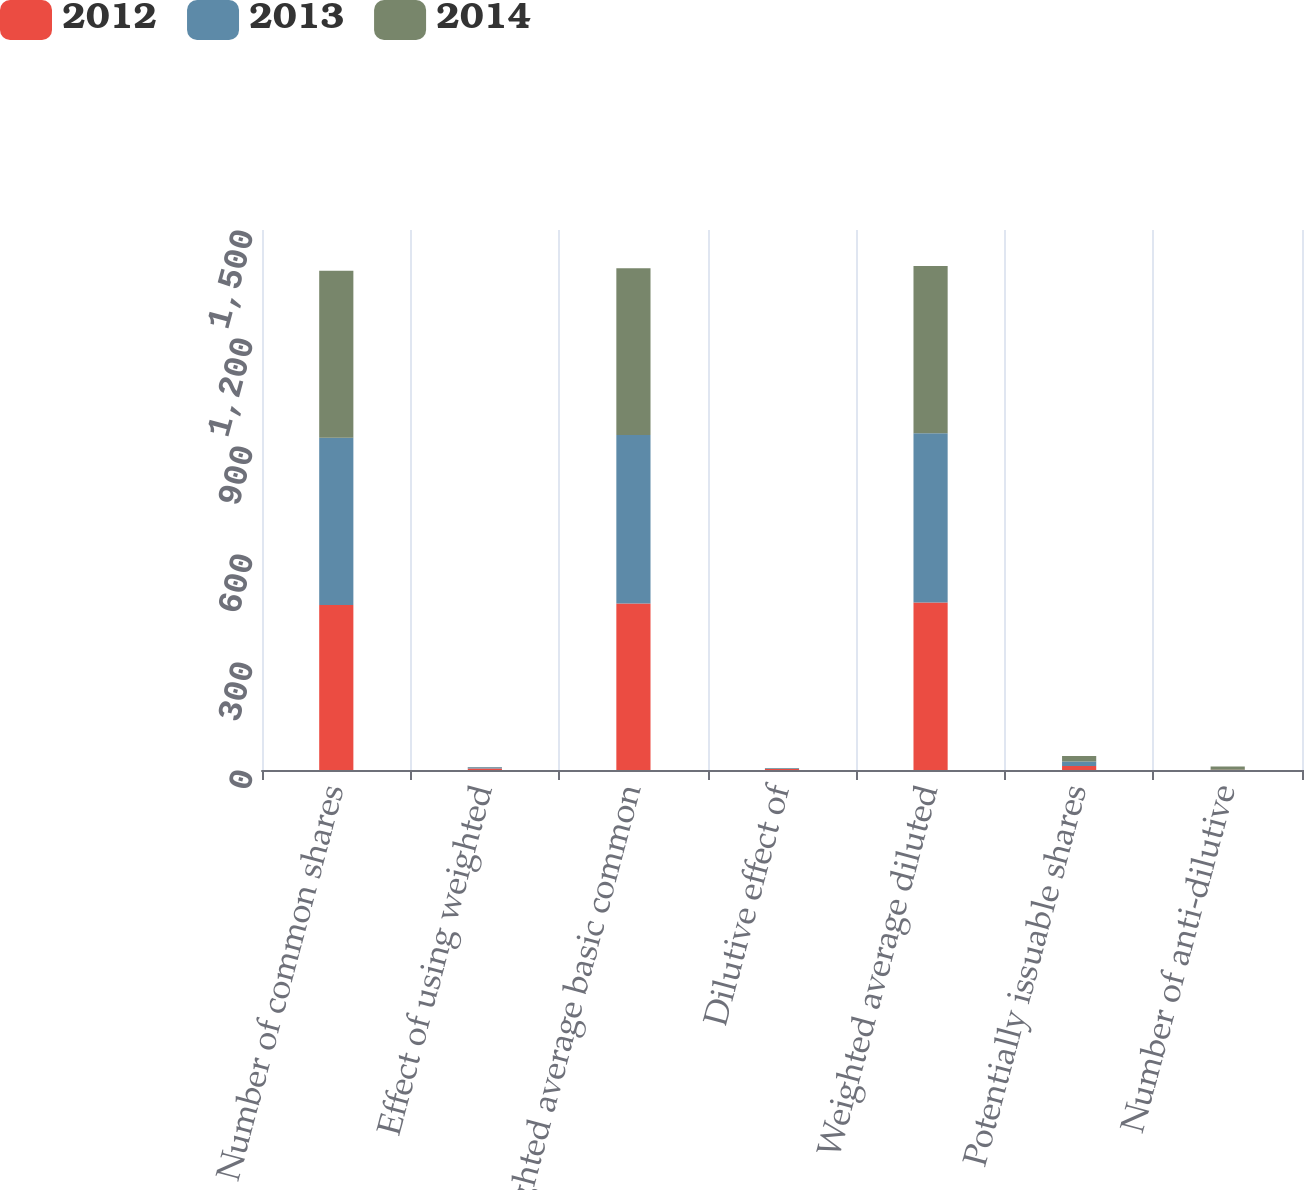Convert chart. <chart><loc_0><loc_0><loc_500><loc_500><stacked_bar_chart><ecel><fcel>Number of common shares<fcel>Effect of using weighted<fcel>Weighted average basic common<fcel>Dilutive effect of<fcel>Weighted average diluted<fcel>Potentially issuable shares<fcel>Number of anti-dilutive<nl><fcel>2012<fcel>458.5<fcel>4.1<fcel>462.6<fcel>3<fcel>465.6<fcel>11.3<fcel>0.4<nl><fcel>2013<fcel>464.3<fcel>3.4<fcel>467.7<fcel>2.1<fcel>469.8<fcel>12.3<fcel>0.1<nl><fcel>2014<fcel>464.2<fcel>0.6<fcel>463.6<fcel>0.8<fcel>464.4<fcel>15.3<fcel>8.9<nl></chart> 